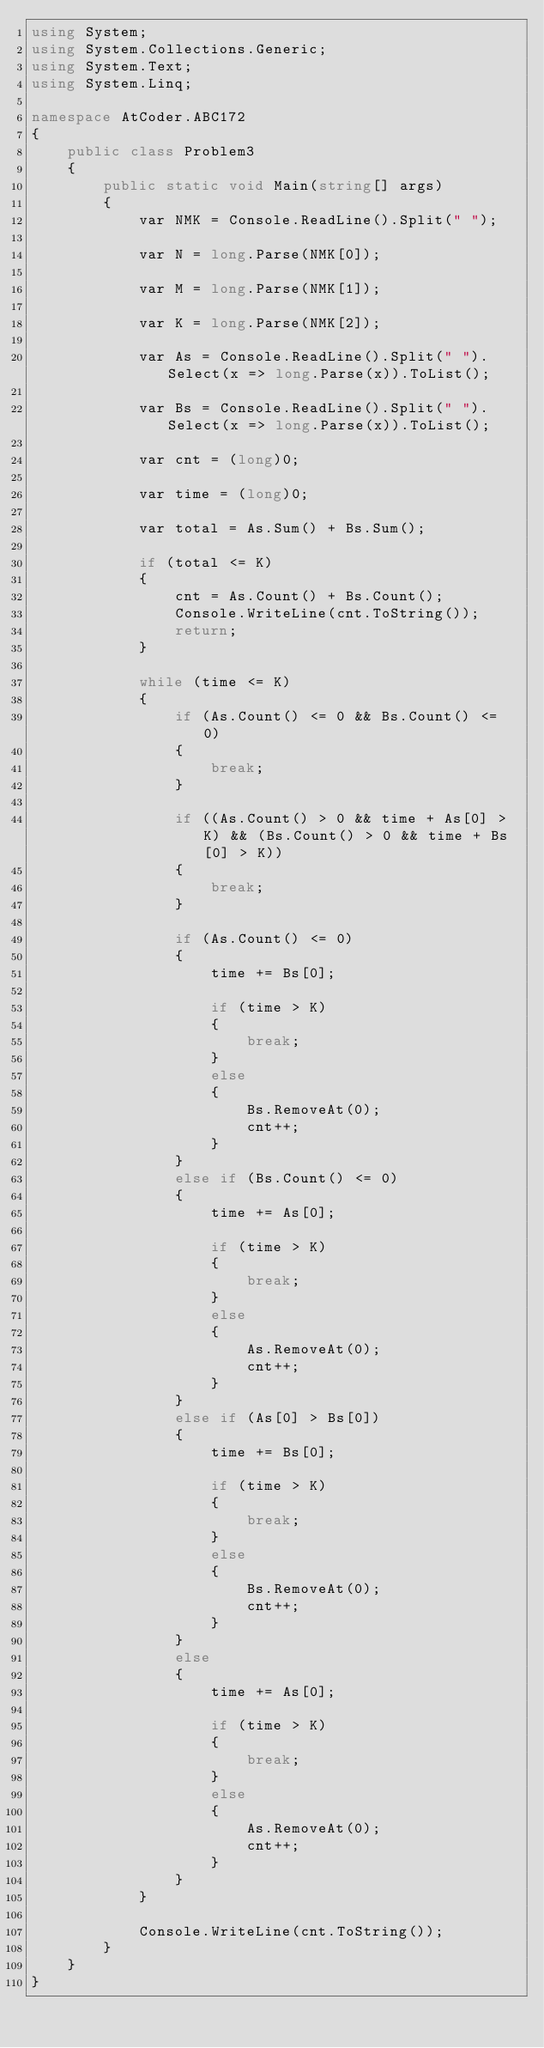<code> <loc_0><loc_0><loc_500><loc_500><_C#_>using System;
using System.Collections.Generic;
using System.Text;
using System.Linq;

namespace AtCoder.ABC172
{
    public class Problem3
    {
        public static void Main(string[] args)
        {
            var NMK = Console.ReadLine().Split(" ");

            var N = long.Parse(NMK[0]);

            var M = long.Parse(NMK[1]);

            var K = long.Parse(NMK[2]);

            var As = Console.ReadLine().Split(" ").Select(x => long.Parse(x)).ToList();

            var Bs = Console.ReadLine().Split(" ").Select(x => long.Parse(x)).ToList();

            var cnt = (long)0;

            var time = (long)0;

            var total = As.Sum() + Bs.Sum();

            if (total <= K)
            {
                cnt = As.Count() + Bs.Count();
                Console.WriteLine(cnt.ToString());
                return;
            }

            while (time <= K)
            {
                if (As.Count() <= 0 && Bs.Count() <= 0)
                {
                    break;
                }
                
                if ((As.Count() > 0 && time + As[0] > K) && (Bs.Count() > 0 && time + Bs[0] > K)) 
                {
                    break;
                }
                
                if (As.Count() <= 0)
                {
                    time += Bs[0];

                    if (time > K)
                    {
                        break;
                    }
                    else
                    {
                        Bs.RemoveAt(0);
                        cnt++;
                    }
                }
                else if (Bs.Count() <= 0)
                {
                    time += As[0];

                    if (time > K)
                    {
                        break;
                    }
                    else
                    {
                        As.RemoveAt(0);
                        cnt++;
                    }
                }
                else if (As[0] > Bs[0])
                {
                    time += Bs[0];

                    if (time > K)
                    {
                        break;
                    }
                    else
                    {
                        Bs.RemoveAt(0);
                        cnt++;
                    }
                }
                else
                {
                    time += As[0];
                    
                    if (time > K)
                    {
                        break;
                    }
                    else
                    {
                        As.RemoveAt(0);
                        cnt++;
                    }
                }
            }

            Console.WriteLine(cnt.ToString());
        }
    }
}
</code> 